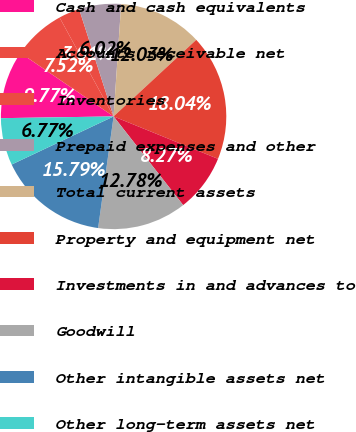<chart> <loc_0><loc_0><loc_500><loc_500><pie_chart><fcel>Cash and cash equivalents<fcel>Accounts receivable net<fcel>Inventories<fcel>Prepaid expenses and other<fcel>Total current assets<fcel>Property and equipment net<fcel>Investments in and advances to<fcel>Goodwill<fcel>Other intangible assets net<fcel>Other long-term assets net<nl><fcel>9.77%<fcel>7.52%<fcel>3.01%<fcel>6.02%<fcel>12.03%<fcel>18.04%<fcel>8.27%<fcel>12.78%<fcel>15.79%<fcel>6.77%<nl></chart> 